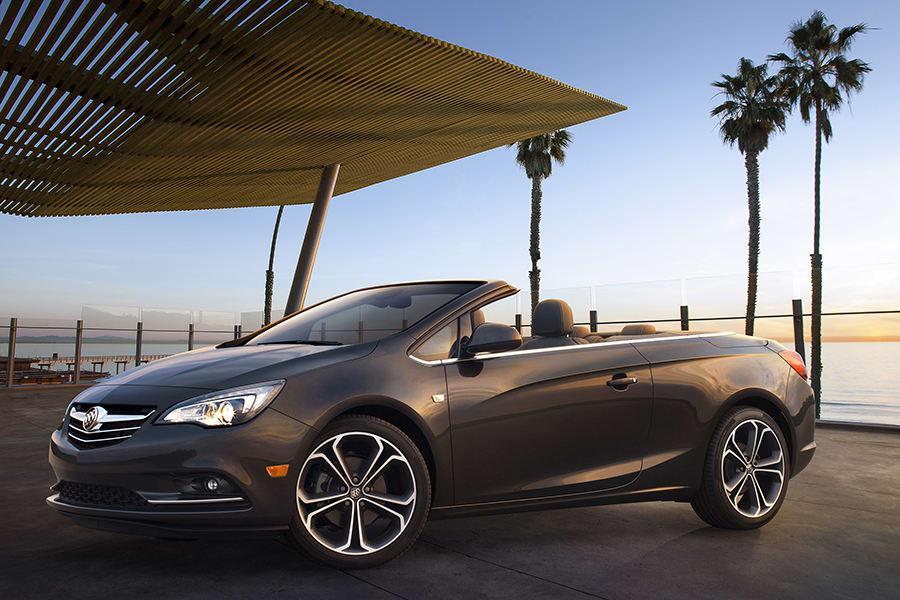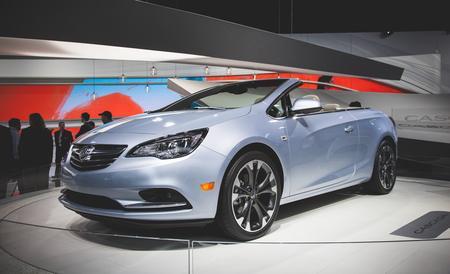The first image is the image on the left, the second image is the image on the right. For the images shown, is this caption "The left image contains a convertible that is facing towards the left." true? Answer yes or no. Yes. 